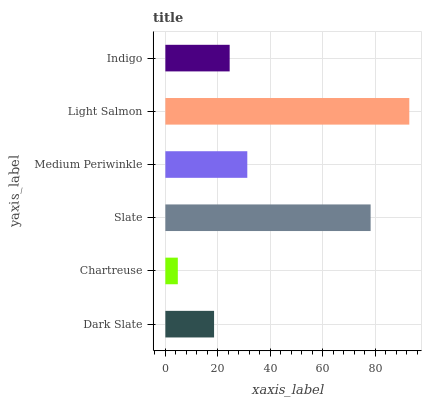Is Chartreuse the minimum?
Answer yes or no. Yes. Is Light Salmon the maximum?
Answer yes or no. Yes. Is Slate the minimum?
Answer yes or no. No. Is Slate the maximum?
Answer yes or no. No. Is Slate greater than Chartreuse?
Answer yes or no. Yes. Is Chartreuse less than Slate?
Answer yes or no. Yes. Is Chartreuse greater than Slate?
Answer yes or no. No. Is Slate less than Chartreuse?
Answer yes or no. No. Is Medium Periwinkle the high median?
Answer yes or no. Yes. Is Indigo the low median?
Answer yes or no. Yes. Is Slate the high median?
Answer yes or no. No. Is Slate the low median?
Answer yes or no. No. 